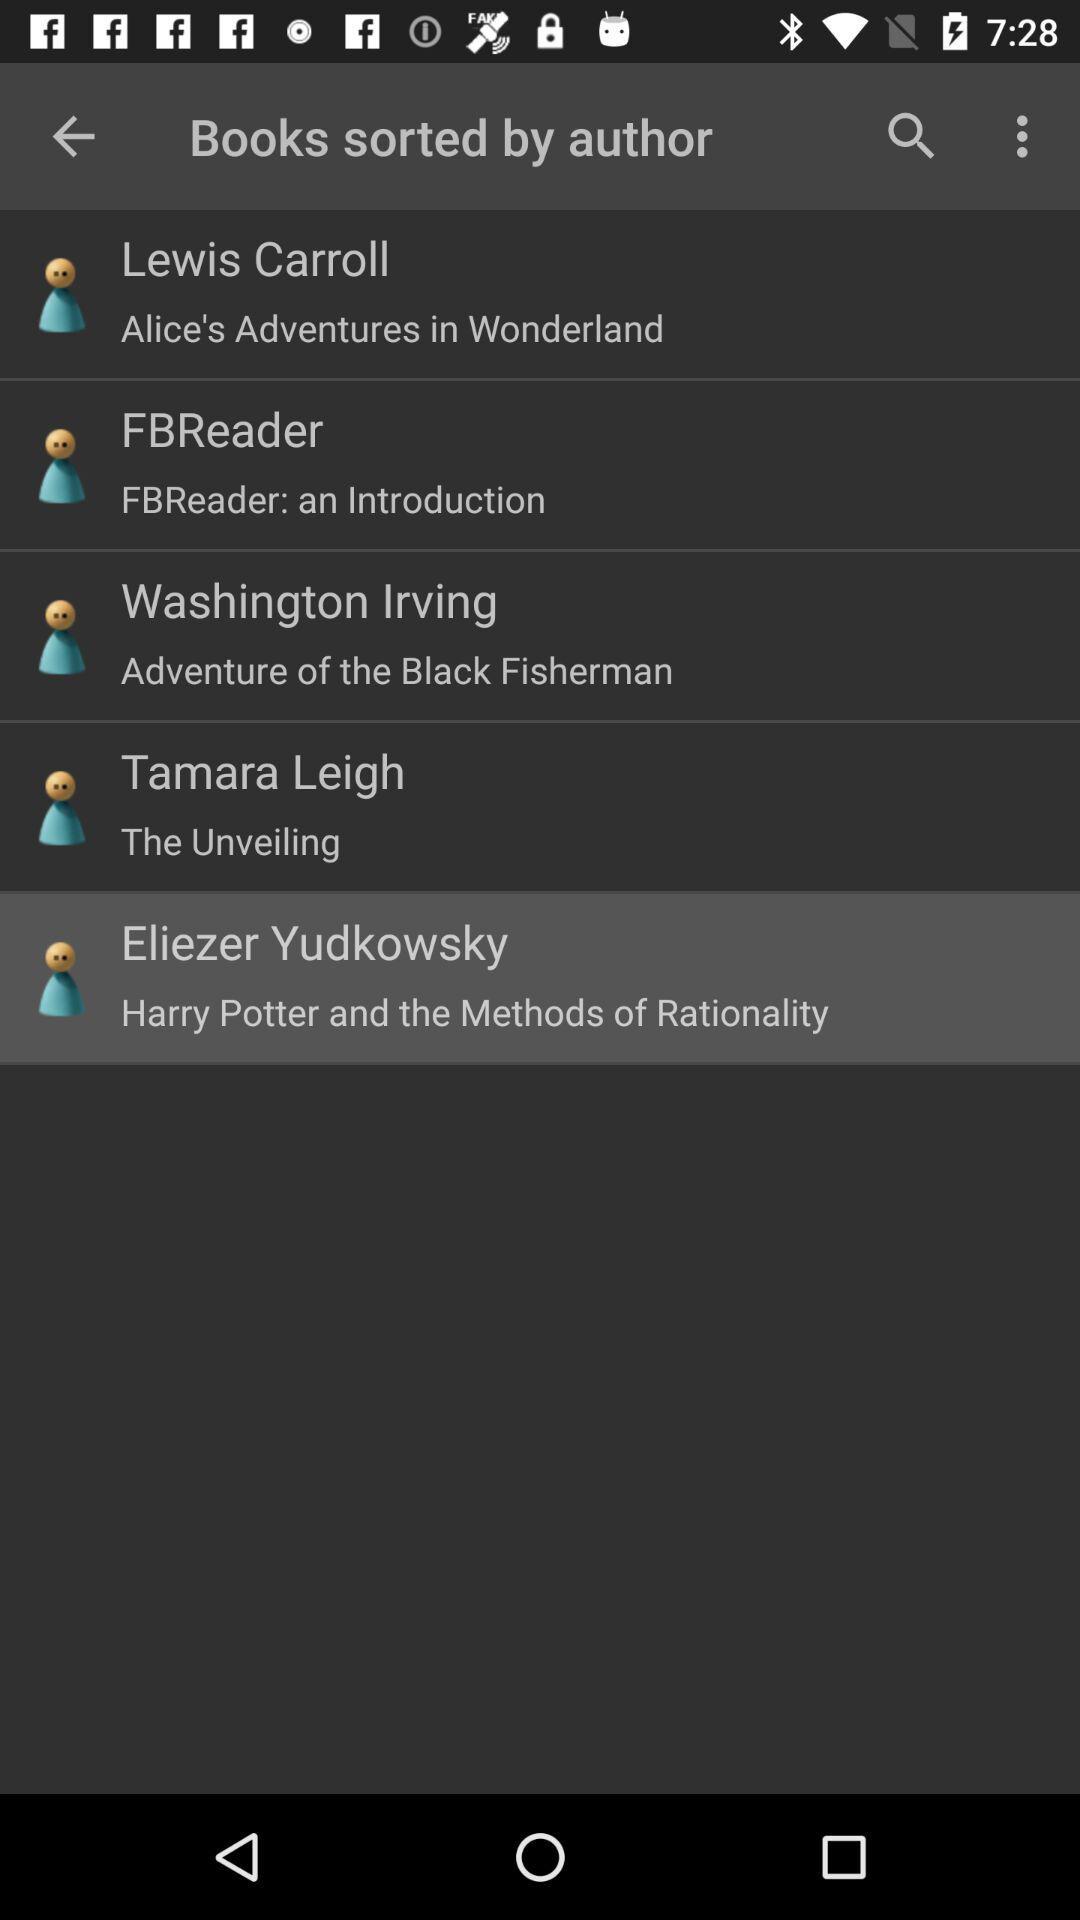Who is the author of "Harry Potter and the Methods of Rationality"? The author is Eliezer Yudkowsky. 